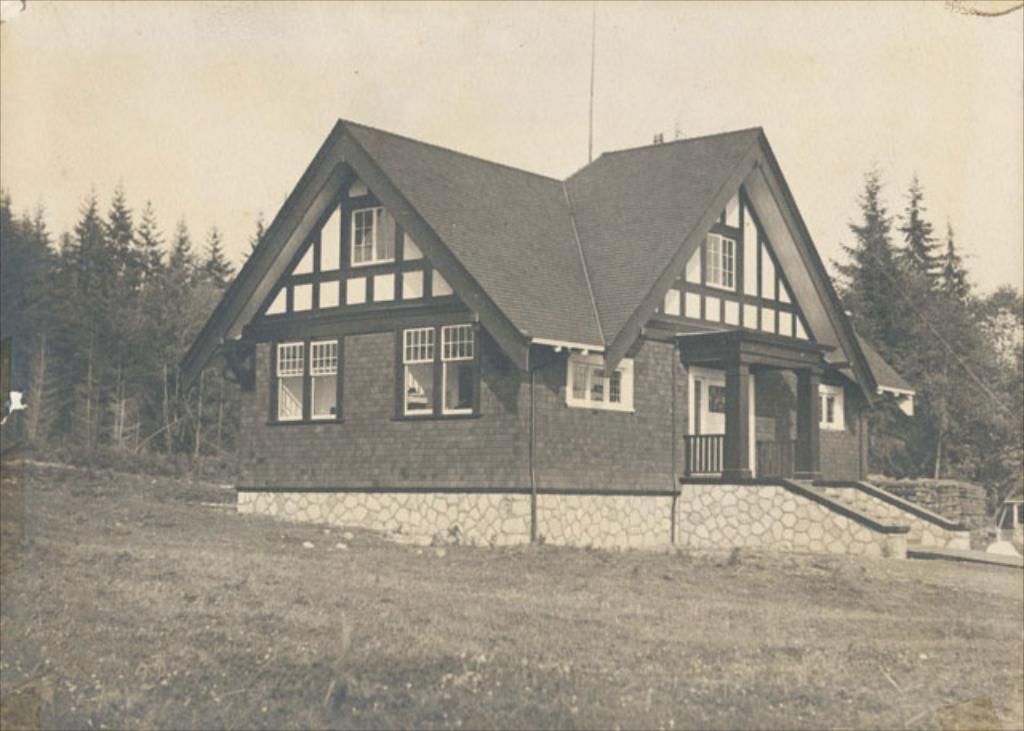What is the main structure in the center of the image? There is a home in the center of the image. What can be seen in the background of the image? There are trees in the background of the image. What type of vegetation is on the ground in the image? There is grass on the ground in the image. How would you describe the sky in the image? The sky is cloudy in the image. How many horses are tied to the wire fence in the image? There are no horses or wire fence present in the image. 